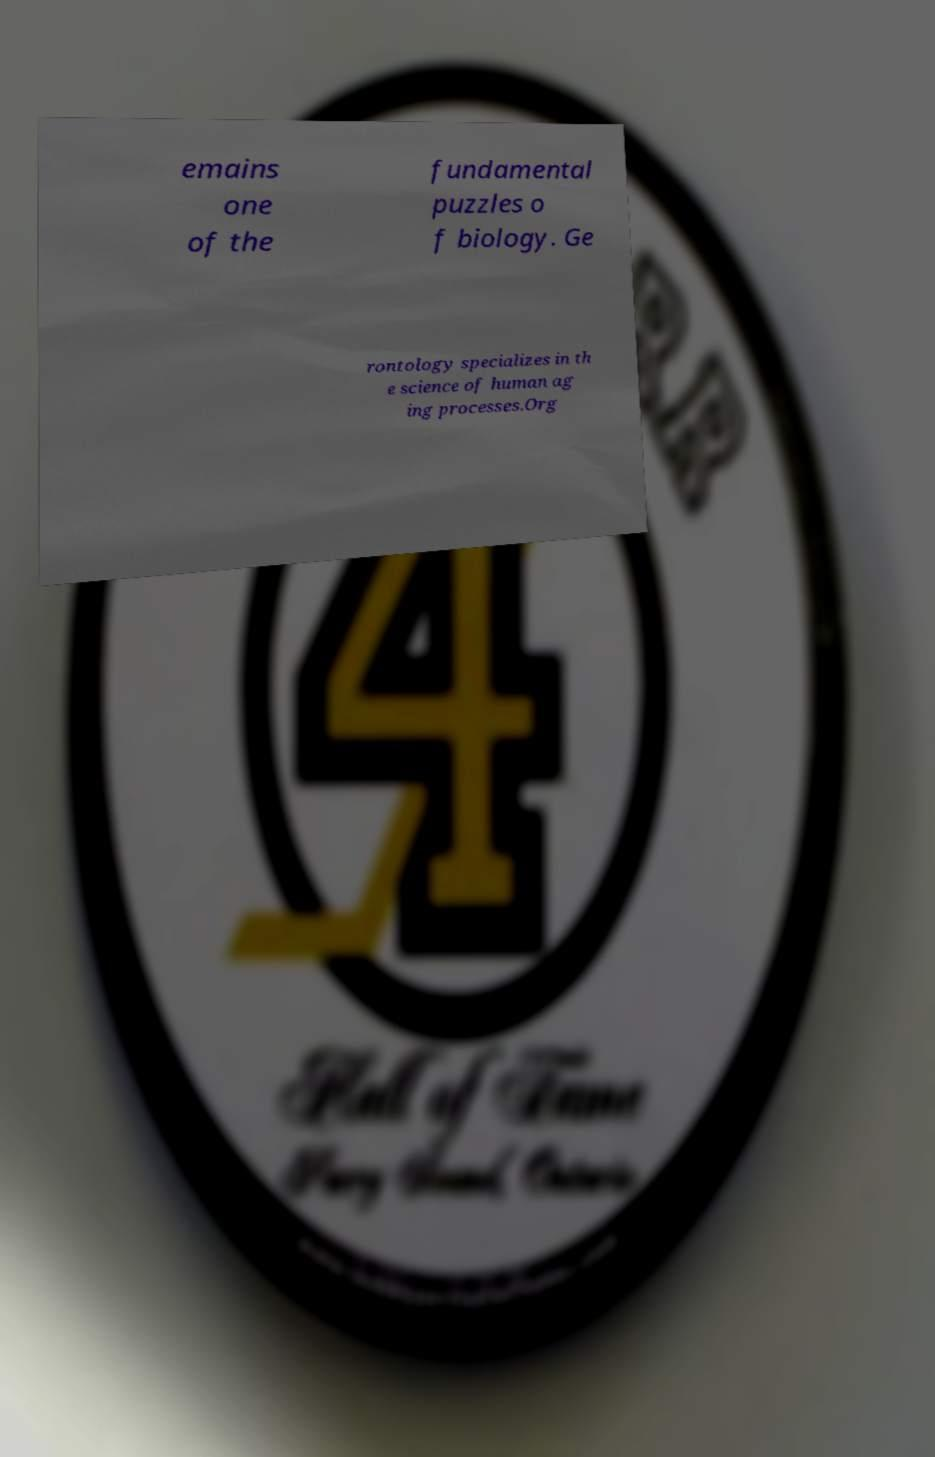What messages or text are displayed in this image? I need them in a readable, typed format. emains one of the fundamental puzzles o f biology. Ge rontology specializes in th e science of human ag ing processes.Org 